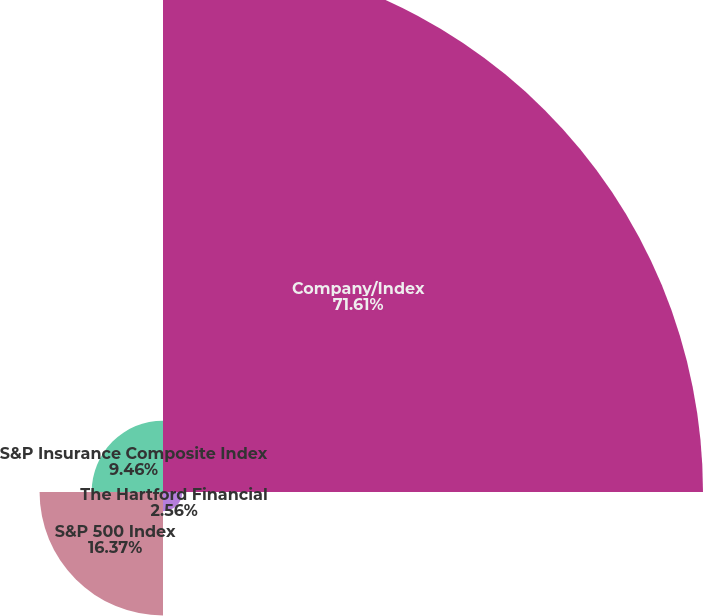Convert chart to OTSL. <chart><loc_0><loc_0><loc_500><loc_500><pie_chart><fcel>Company/Index<fcel>The Hartford Financial<fcel>S&P 500 Index<fcel>S&P Insurance Composite Index<nl><fcel>71.62%<fcel>2.56%<fcel>16.37%<fcel>9.46%<nl></chart> 